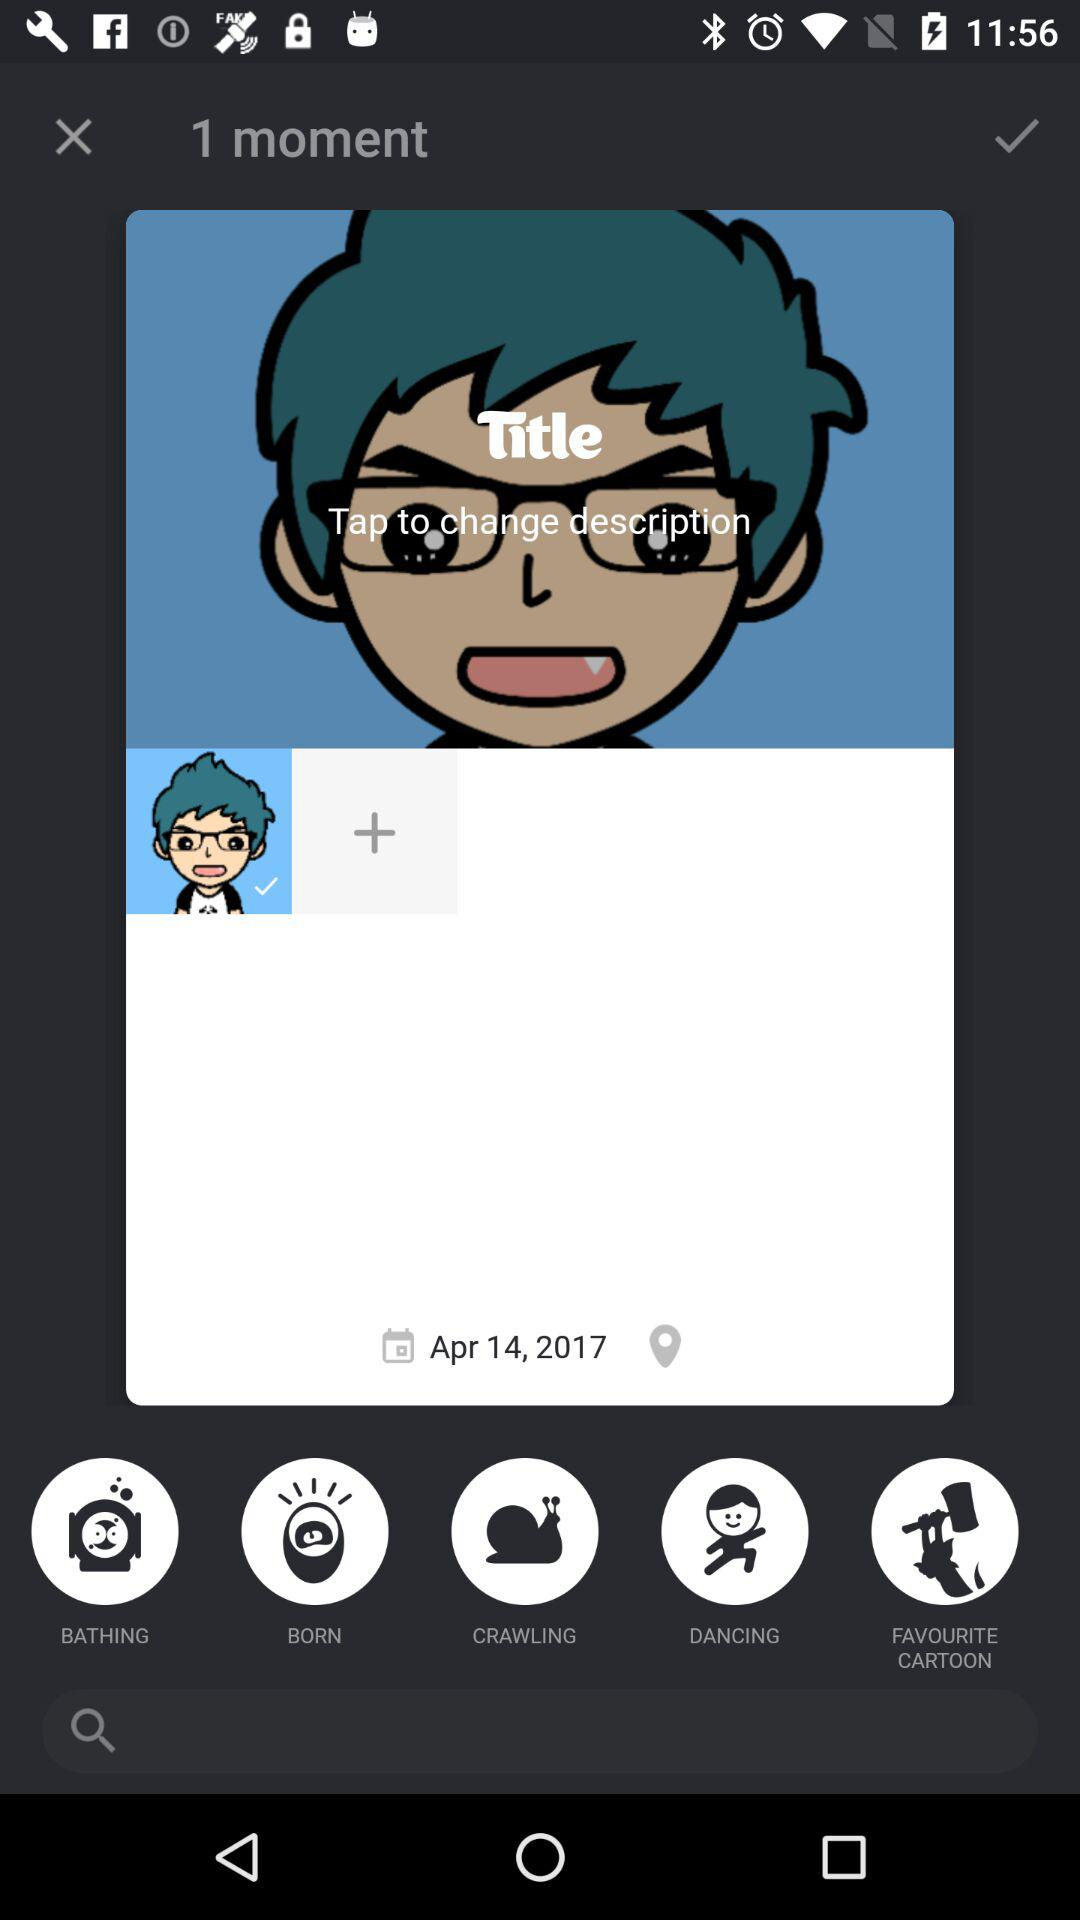What is the date? The date is April 14, 2017. 